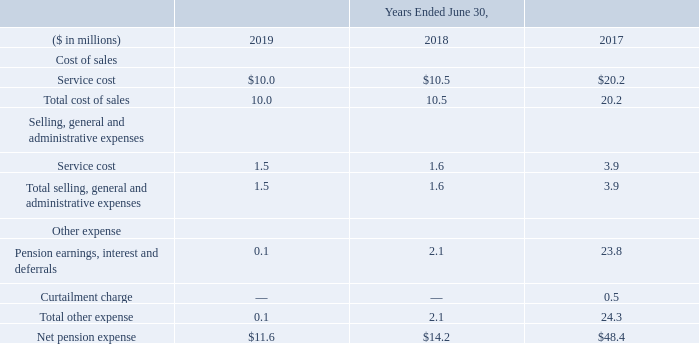The service cost component of net pension expense represents the estimated cost of future pension liabilities earned associated with active employees. The pension earnings, interest and deferrals (“pension EID”) is comprised of the expected return on plan assets, interest costs on the projected benefit obligations of the plans and amortization of actuarial gains and losses and prior service costs.
Net pension expense is recorded in accounts that are included in both the cost of sales and selling, general and administrative expenses based on the function of the associated employees and in other income (expense), net. The following is a summary of the classification of net pension expense for the years ended June 30, 2019, 2018 and 2017:
As of June 30, 2019 and 2018, amounts capitalized in gross inventory were $1.7 million and $1.7 million, respectively.
What does the service cost component of net pension expense represent? The estimated cost of future pension liabilities earned associated with active employees. the pension earnings, interest and deferrals (“pension eid”) is comprised of the expected return on plan assets, interest costs on the projected benefit obligations of the plans and amortization of actuarial gains and losses and prior service costs. How is net pension expense recorded? Recorded in accounts that are included in both the cost of sales and selling, general and administrative expenses based on the function of the associated employees and in other income (expense), net. In which years is the net pension expense recorded? 2019, 2018, 2017. In which year was the total cost of sales the largest? 20.2>10.5>10.0
Answer: 2017. What was the change in Total selling, general and administrative expenses in 2019 from 2018?
Answer scale should be: million. 1.5-1.6
Answer: -0.1. What was the percentage change in Total selling, general and administrative expenses in 2019 from 2018?
Answer scale should be: percent. (1.5-1.6)/1.6
Answer: -6.25. 